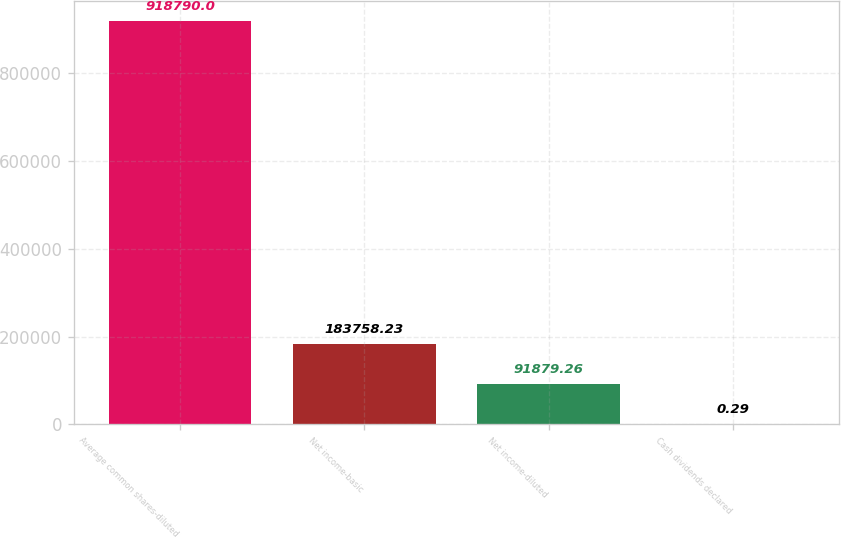Convert chart. <chart><loc_0><loc_0><loc_500><loc_500><bar_chart><fcel>Average common shares-diluted<fcel>Net income-basic<fcel>Net income-diluted<fcel>Cash dividends declared<nl><fcel>918790<fcel>183758<fcel>91879.3<fcel>0.29<nl></chart> 